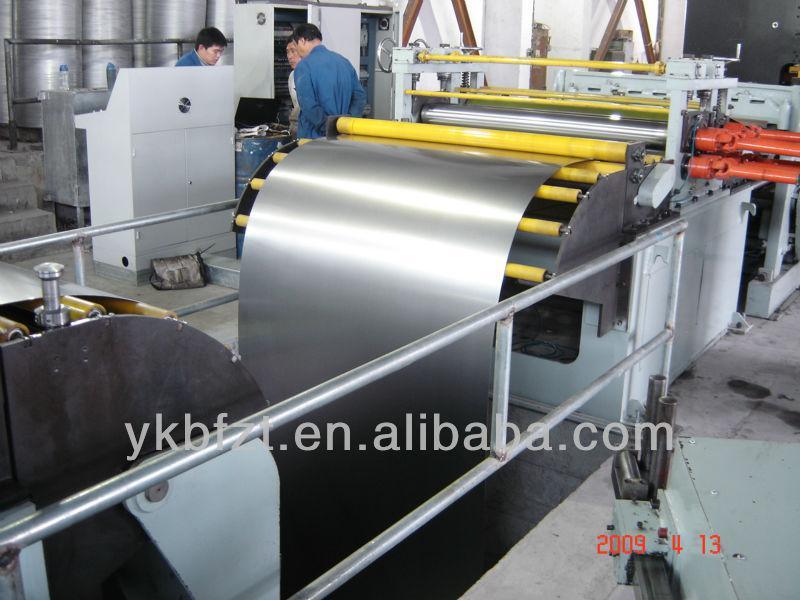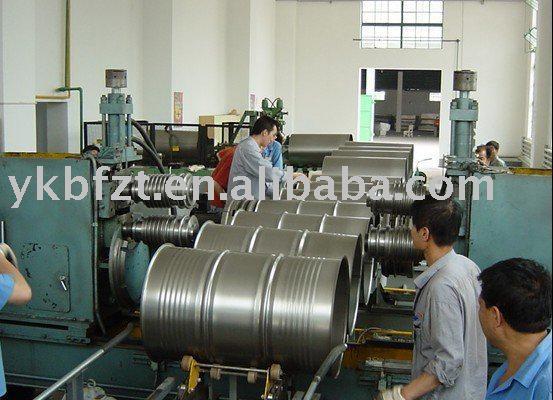The first image is the image on the left, the second image is the image on the right. For the images displayed, is the sentence "People work near silver barrels in at least one of the images." factually correct? Answer yes or no. Yes. The first image is the image on the left, the second image is the image on the right. For the images shown, is this caption "An image shows silver barrels on their sides flanked by greenish-bluish painted equipment, and a man in a blue shirt on the far right." true? Answer yes or no. Yes. 